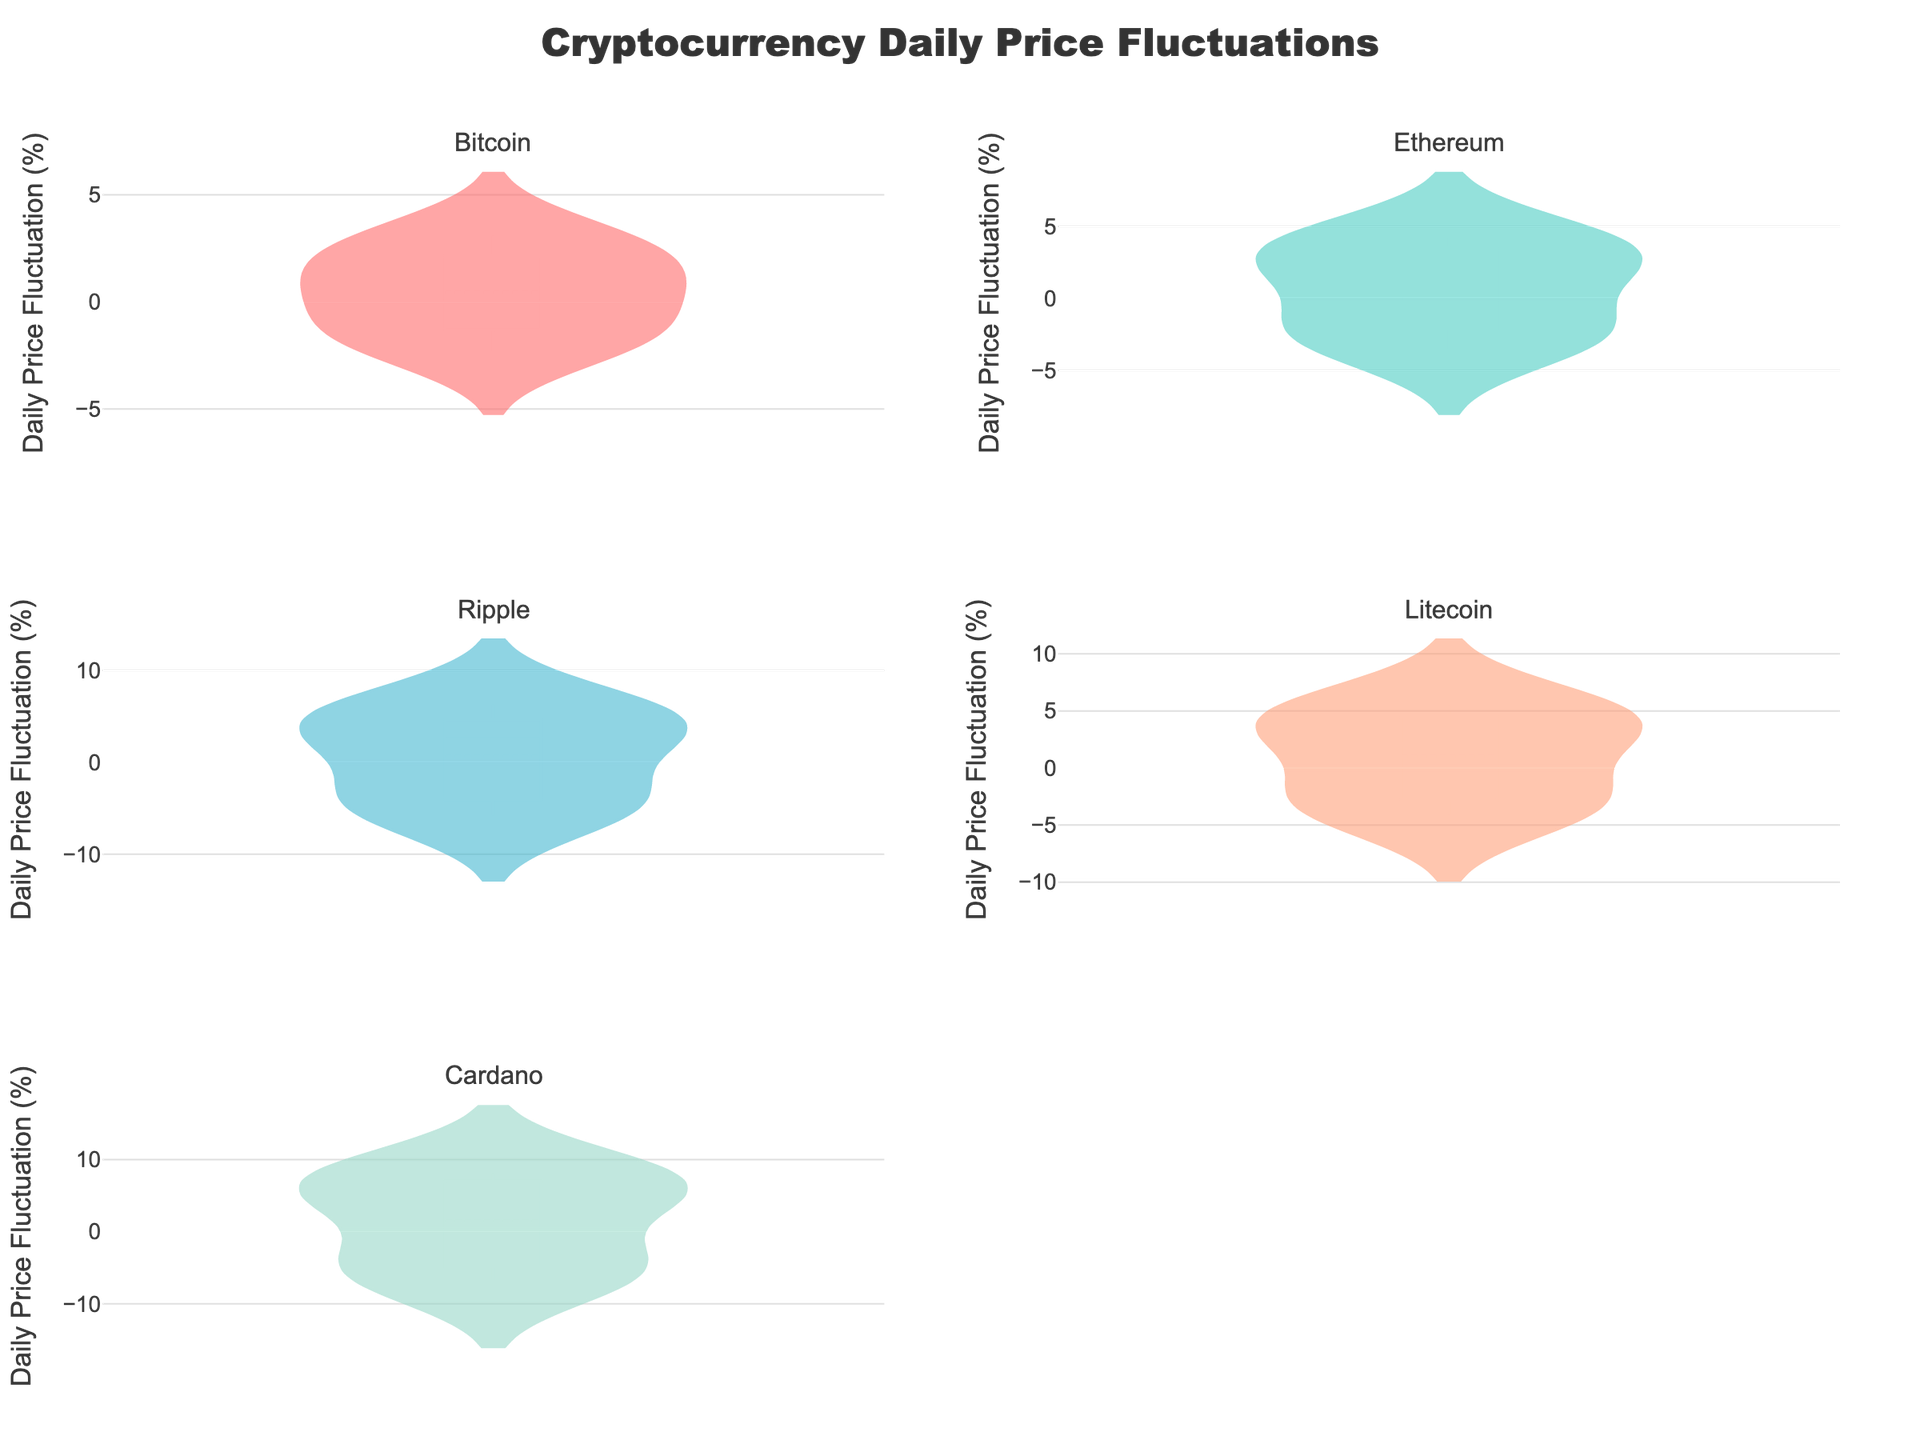What is the title of the overall plot? The title of the overall plot is located at the top center of the figure. The exact wording is "Cryptocurrency Daily Price Fluctuations".
Answer: "Cryptocurrency Daily Price Fluctuations" Which cryptocurrency shows the highest daily price fluctuation on average? To find which cryptocurrency shows the highest daily price fluctuation on average, look at the mean line (dashed line) in the violin plots for each cryptocurrency. The cryptocurrency with the highest mean line represents the highest average daily price fluctuation.
Answer: Cardano Which cryptocurrency exhibits the widest range of daily price fluctuations? The range for each cryptocurrency can be determined by looking at the spread of the violin plots. The widest spread indicates the cryptocurrency with the widest range of daily price fluctuations.
Answer: Cardano How does the fluctuation range of Bitcoin compare to that of Ripple? To compare the fluctuation ranges, assess the spreads of the respective violin plots. Bitcoin has a smaller spread, indicating a smaller range of daily price fluctuations compared to Ripple, which has a wider spread.
Answer: Ripple has a wider range What is the approximate maximum daily price fluctuation for Litecoin? The maximum daily price fluctuation can be estimated by looking at the highest point on the Litecoin violin plot. This point corresponds to the highest daily fluctuation value for Litecoin.
Answer: Approximately 5.5% Which two cryptocurrencies have the most similar average daily price fluctuations? Look at the mean lines in the violin plots for all cryptocurrencies. Identify the two whose mean lines are closest to each other.
Answer: Bitcoin and Ethereum Is there any cryptocurrency that shows a slightly low range compared to the others? Assess all the violin plots for their spread. A smaller spread indicates a lower range of daily price fluctuations.
Answer: Bitcoin How does the daily price fluctuation of Ethereum compare to Cardano? Compare the width and spread of the violin plots for Ethereum and Cardano. Cardano has a wider range and therefore greater daily price fluctuations compared to Ethereum.
Answer: Cardano has greater fluctuations What color is used for the Ripple data in the plot? The color used corresponds to one of the predefined colors in the plot and can be identified from Ripple's violin plot.
Answer: '#45B7D1' (Blue) Out of all the cryptocurrencies, which one has the least negative daily price fluctuation? Identify the bottom points of the violin plots for each cryptocurrency. The least negative fluctuation will be represented by the highest bottom point among the plots.
Answer: Bitcoin 